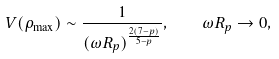<formula> <loc_0><loc_0><loc_500><loc_500>V ( \rho _ { \max } ) \sim \frac { 1 } { ( \omega R _ { p } ) ^ { \frac { 2 ( 7 - p ) } { 5 - p } } } , \quad \omega R _ { p } \rightarrow 0 ,</formula> 